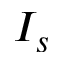Convert formula to latex. <formula><loc_0><loc_0><loc_500><loc_500>I _ { s }</formula> 